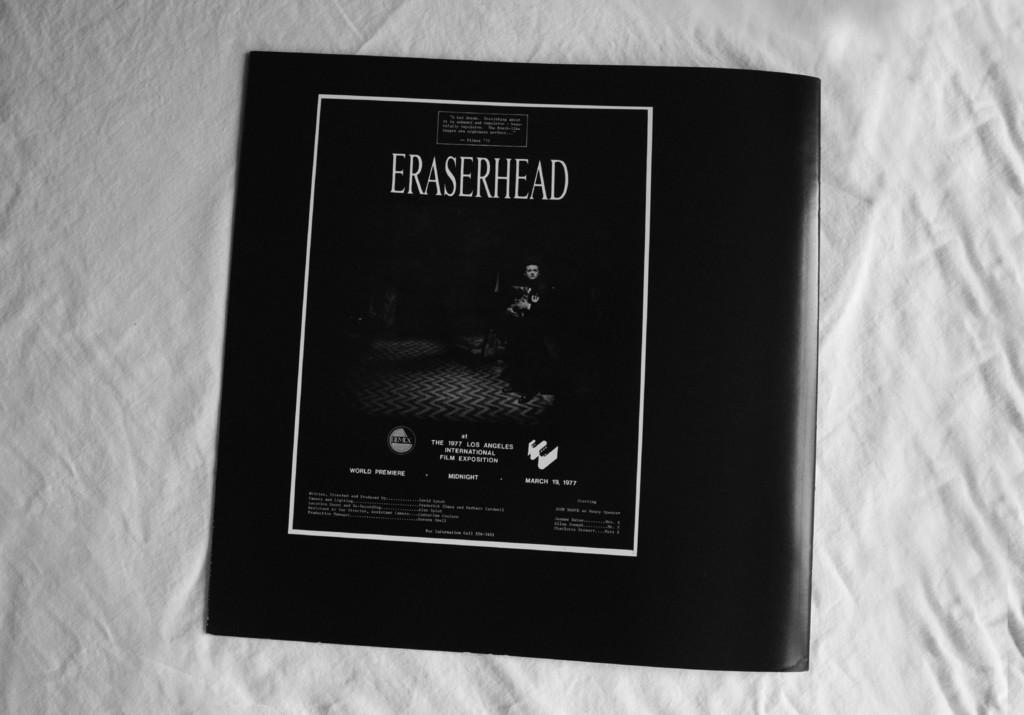<image>
Create a compact narrative representing the image presented. white fabric background with black eraserhead cd laying on it 